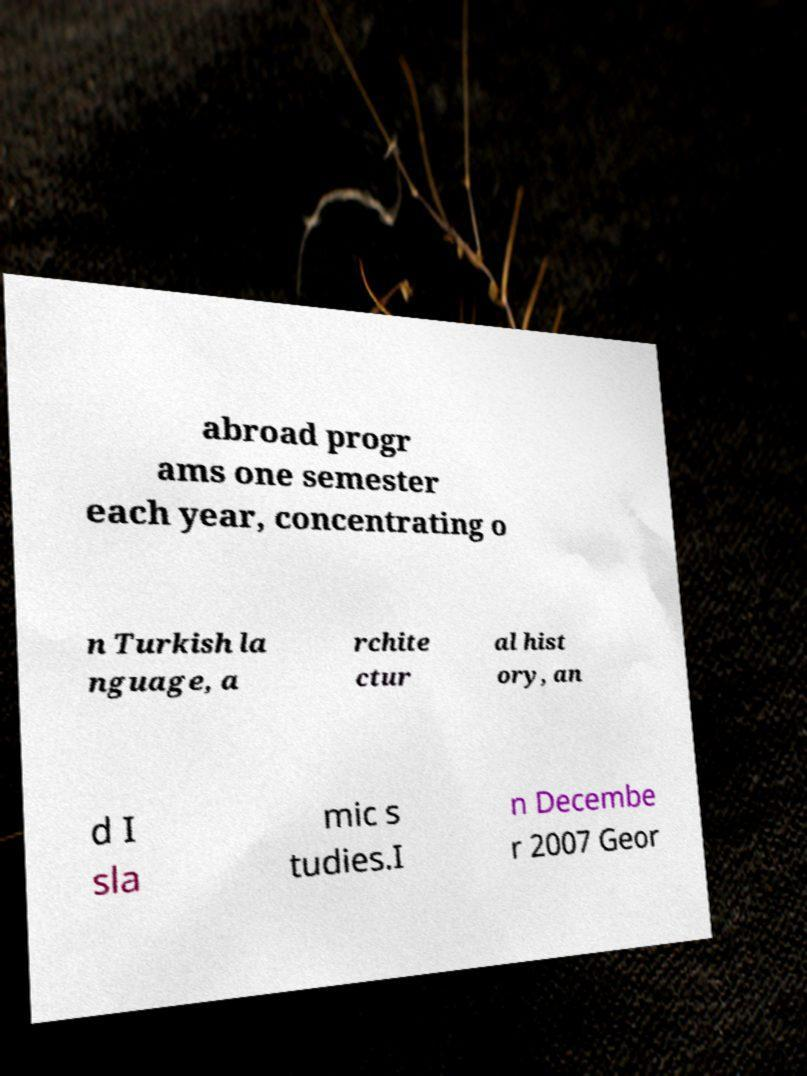There's text embedded in this image that I need extracted. Can you transcribe it verbatim? abroad progr ams one semester each year, concentrating o n Turkish la nguage, a rchite ctur al hist ory, an d I sla mic s tudies.I n Decembe r 2007 Geor 